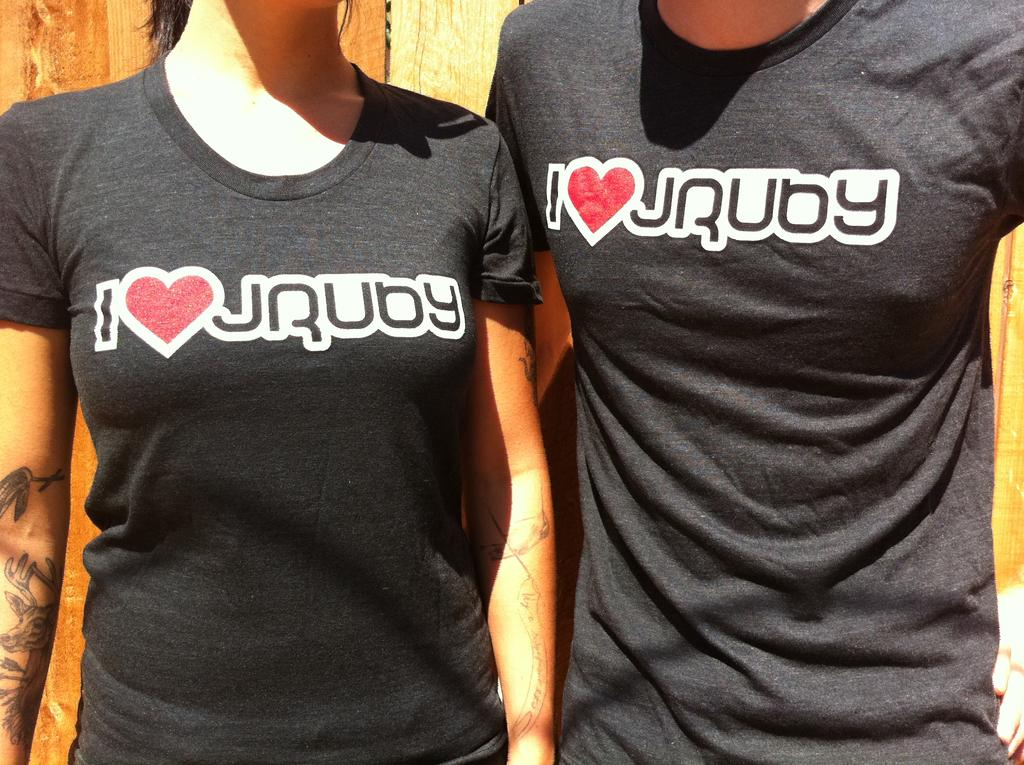<image>
Provide a brief description of the given image. the word ruby is on two of their shirts 